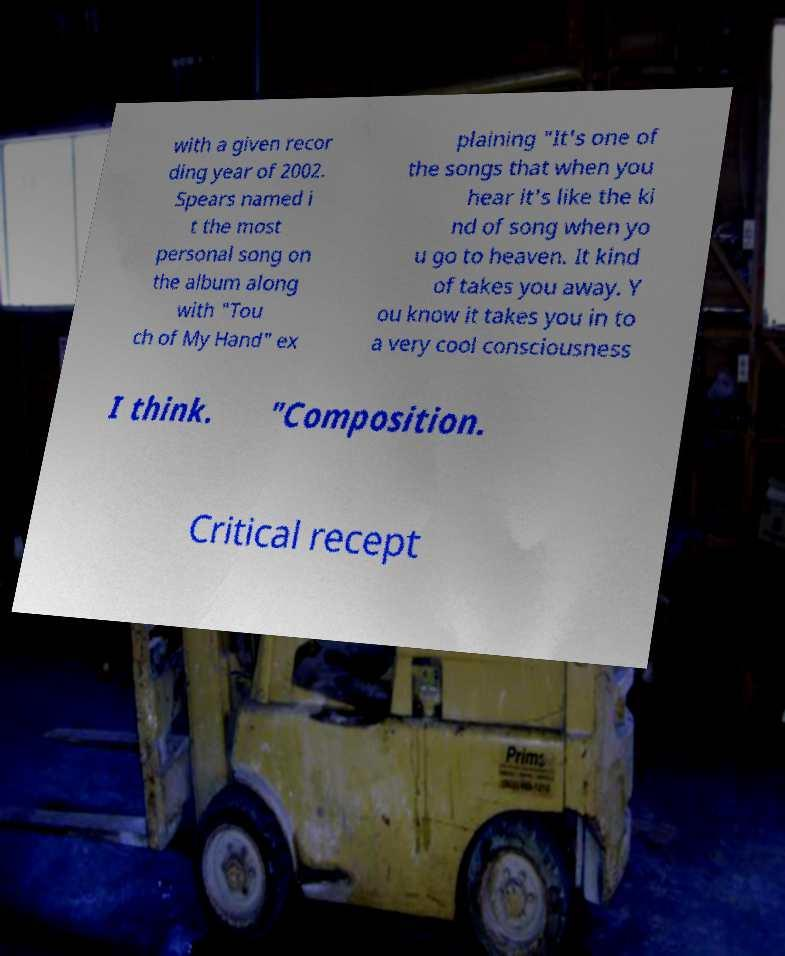Can you accurately transcribe the text from the provided image for me? with a given recor ding year of 2002. Spears named i t the most personal song on the album along with "Tou ch of My Hand" ex plaining "It's one of the songs that when you hear it's like the ki nd of song when yo u go to heaven. It kind of takes you away. Y ou know it takes you in to a very cool consciousness I think. "Composition. Critical recept 